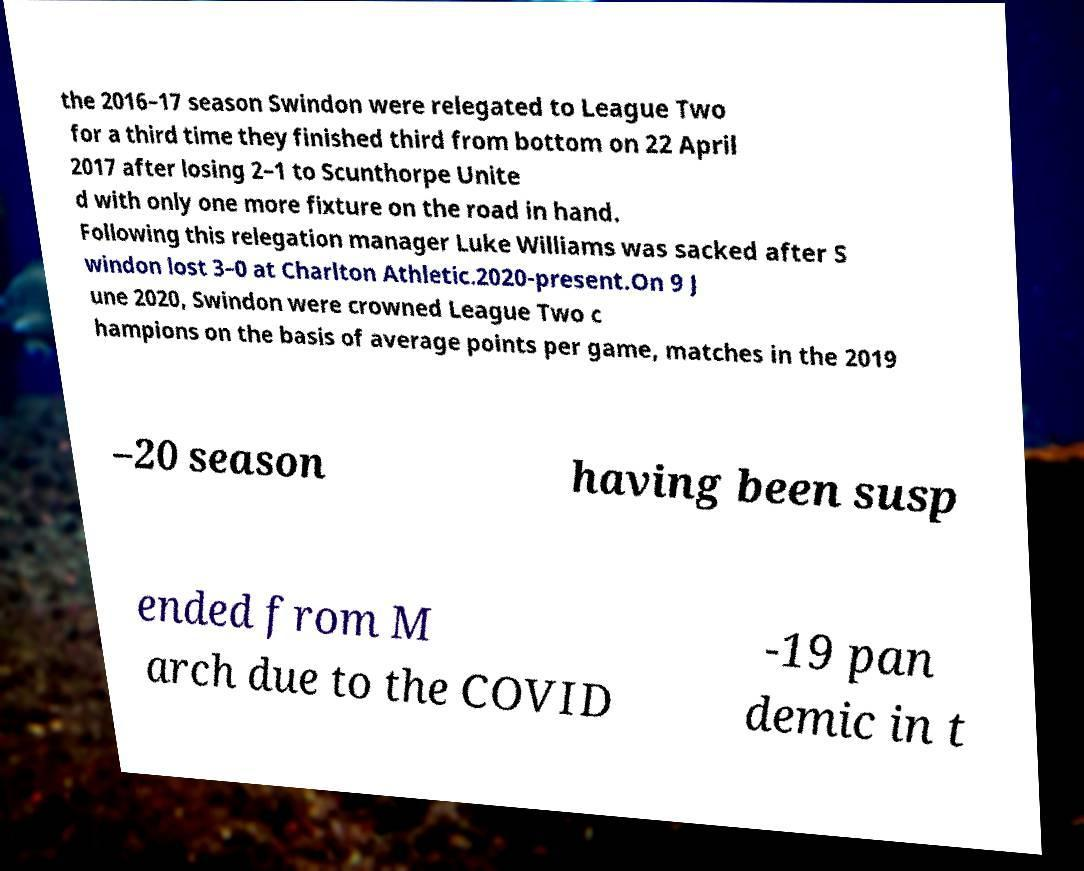Could you assist in decoding the text presented in this image and type it out clearly? the 2016–17 season Swindon were relegated to League Two for a third time they finished third from bottom on 22 April 2017 after losing 2–1 to Scunthorpe Unite d with only one more fixture on the road in hand. Following this relegation manager Luke Williams was sacked after S windon lost 3–0 at Charlton Athletic.2020-present.On 9 J une 2020, Swindon were crowned League Two c hampions on the basis of average points per game, matches in the 2019 –20 season having been susp ended from M arch due to the COVID -19 pan demic in t 